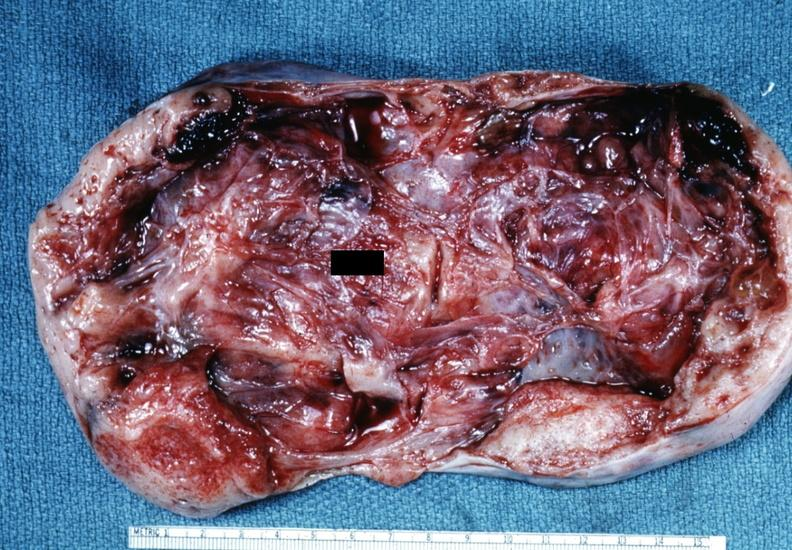where does this belong to?
Answer the question using a single word or phrase. Female reproductive system 